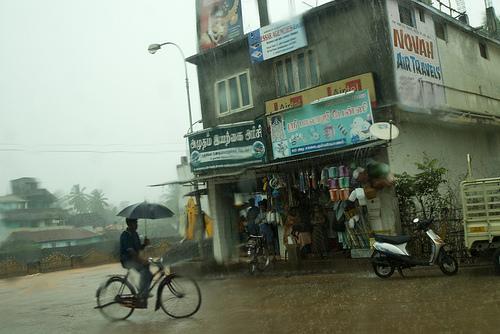How many people are riding a bike?
Give a very brief answer. 1. 